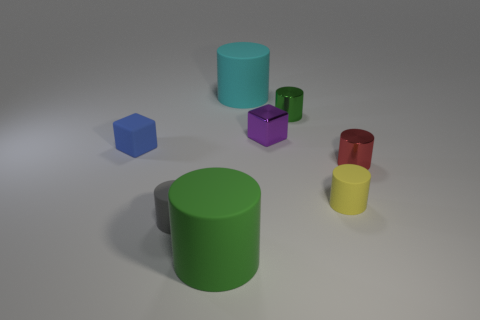Are there any green metallic spheres that have the same size as the purple cube?
Your answer should be very brief. No. What number of things are either big things to the right of the big green matte thing or small shiny things that are in front of the matte cube?
Ensure brevity in your answer.  2. What is the color of the large rubber cylinder in front of the tiny rubber cylinder that is on the right side of the large green thing?
Provide a succinct answer. Green. What is the color of the cylinder that is the same material as the tiny green thing?
Make the answer very short. Red. What number of objects are either cylinders or gray rubber cubes?
Give a very brief answer. 6. The yellow rubber thing that is the same size as the gray cylinder is what shape?
Provide a short and direct response. Cylinder. How many big things are both behind the small blue matte thing and in front of the blue rubber thing?
Give a very brief answer. 0. There is a large cylinder behind the tiny blue matte block; what is it made of?
Your answer should be very brief. Rubber. What size is the green cylinder that is made of the same material as the small yellow object?
Ensure brevity in your answer.  Large. There is a shiny cylinder that is in front of the green metallic thing; is it the same size as the green cylinder that is left of the tiny green metallic cylinder?
Your answer should be compact. No. 